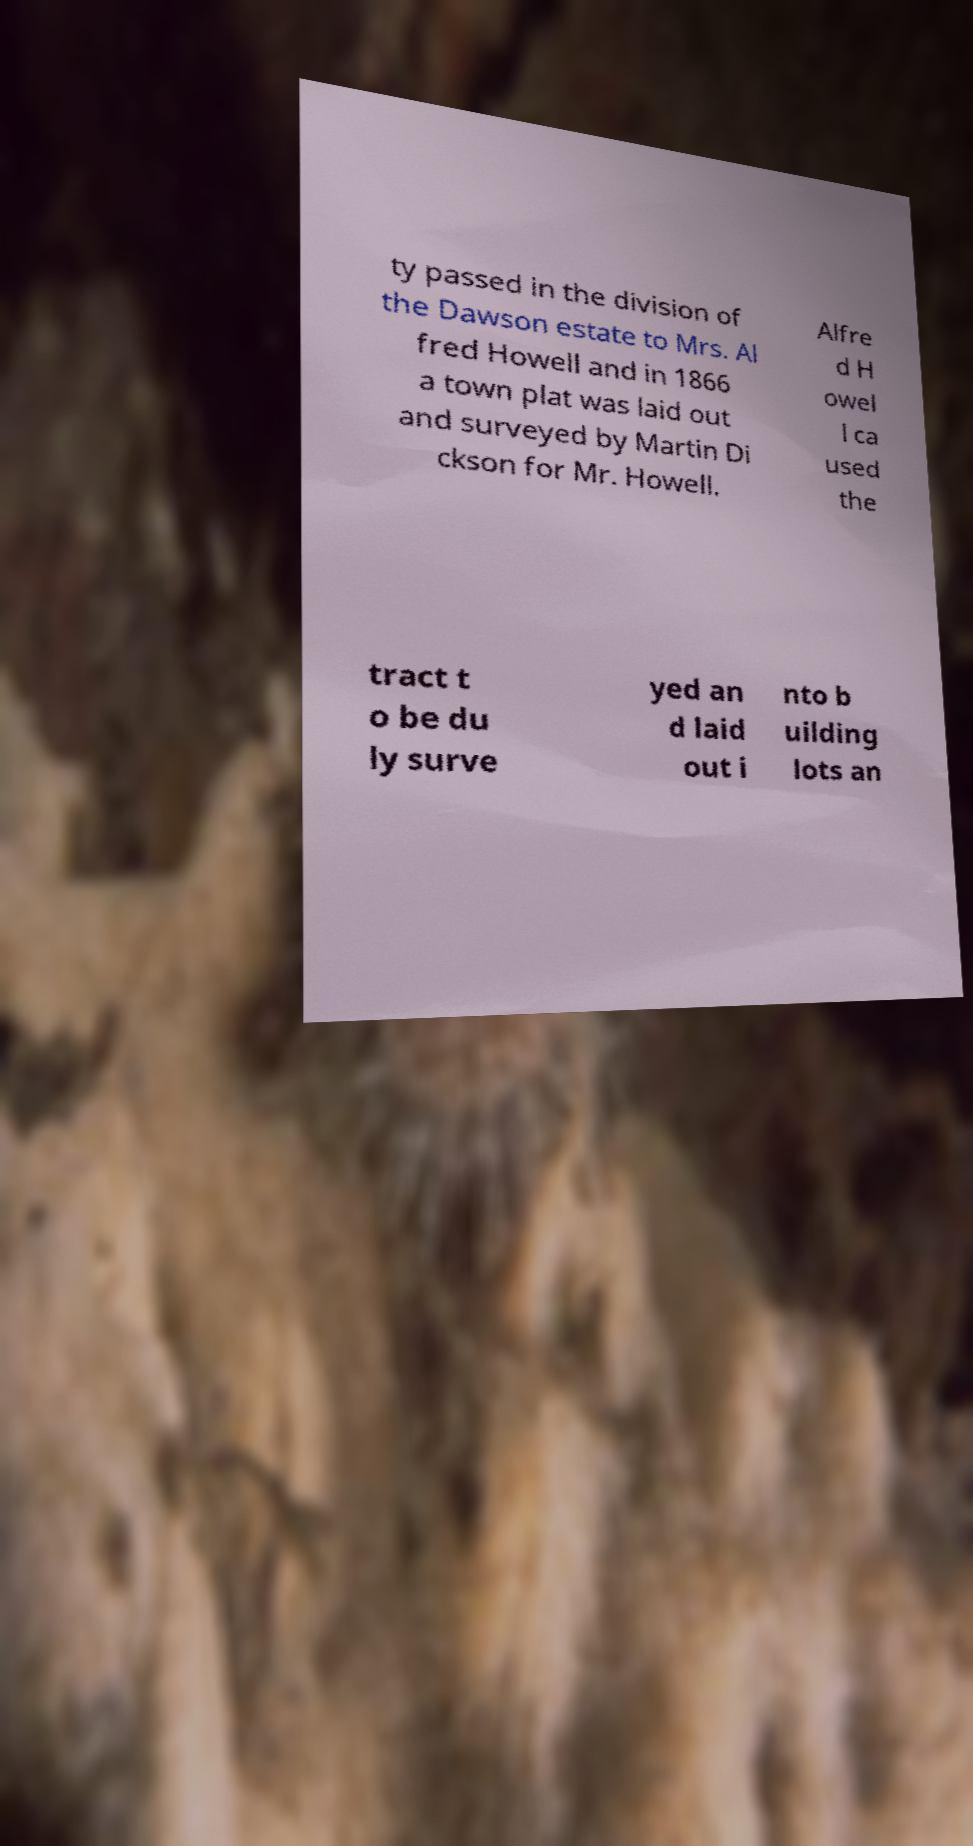I need the written content from this picture converted into text. Can you do that? ty passed in the division of the Dawson estate to Mrs. Al fred Howell and in 1866 a town plat was laid out and surveyed by Martin Di ckson for Mr. Howell. Alfre d H owel l ca used the tract t o be du ly surve yed an d laid out i nto b uilding lots an 